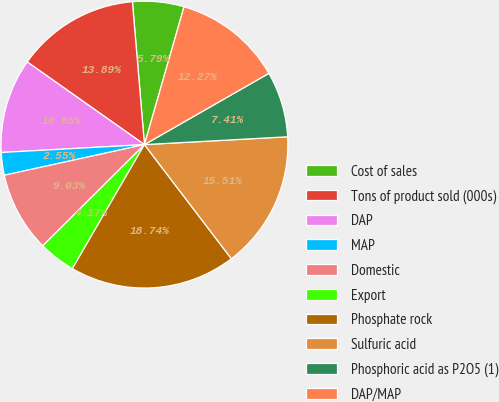Convert chart. <chart><loc_0><loc_0><loc_500><loc_500><pie_chart><fcel>Cost of sales<fcel>Tons of product sold (000s)<fcel>DAP<fcel>MAP<fcel>Domestic<fcel>Export<fcel>Phosphate rock<fcel>Sulfuric acid<fcel>Phosphoric acid as P2O5 (1)<fcel>DAP/MAP<nl><fcel>5.79%<fcel>13.89%<fcel>10.65%<fcel>2.55%<fcel>9.03%<fcel>4.17%<fcel>18.74%<fcel>15.51%<fcel>7.41%<fcel>12.27%<nl></chart> 